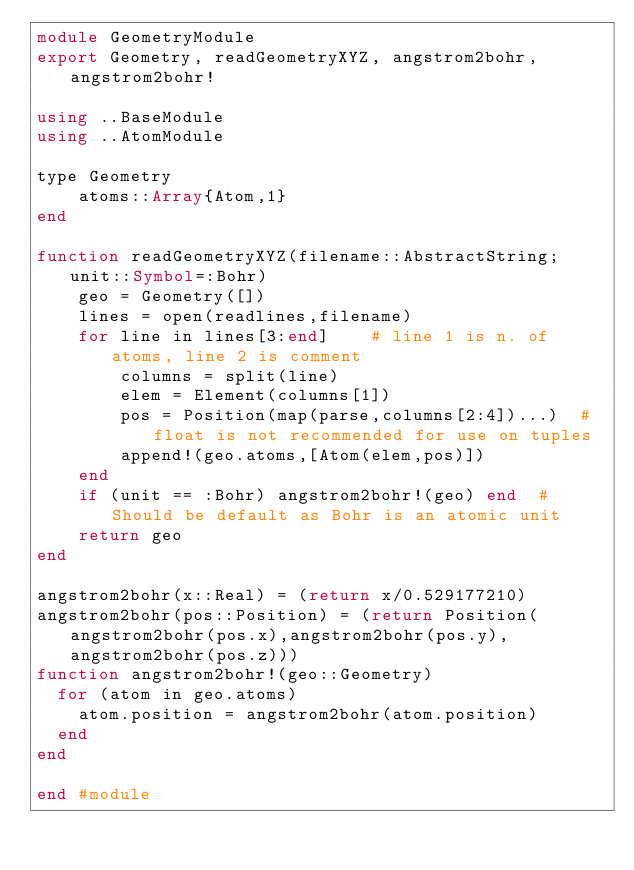Convert code to text. <code><loc_0><loc_0><loc_500><loc_500><_Julia_>module GeometryModule
export Geometry, readGeometryXYZ, angstrom2bohr, angstrom2bohr!

using ..BaseModule
using ..AtomModule

type Geometry
	atoms::Array{Atom,1}
end

function readGeometryXYZ(filename::AbstractString; unit::Symbol=:Bohr)
	geo = Geometry([])
	lines = open(readlines,filename)
	for line in lines[3:end]	# line 1 is n. of atoms, line 2 is comment
		columns = split(line)
		elem = Element(columns[1])
		pos = Position(map(parse,columns[2:4])...)	# float is not recommended for use on tuples
		append!(geo.atoms,[Atom(elem,pos)])
	end
	if (unit == :Bohr) angstrom2bohr!(geo) end	# Should be default as Bohr is an atomic unit
	return geo
end

angstrom2bohr(x::Real) = (return x/0.529177210)
angstrom2bohr(pos::Position) = (return Position(angstrom2bohr(pos.x),angstrom2bohr(pos.y),angstrom2bohr(pos.z)))
function angstrom2bohr!(geo::Geometry)
  for (atom in geo.atoms)
    atom.position = angstrom2bohr(atom.position)
  end
end

end #module
</code> 